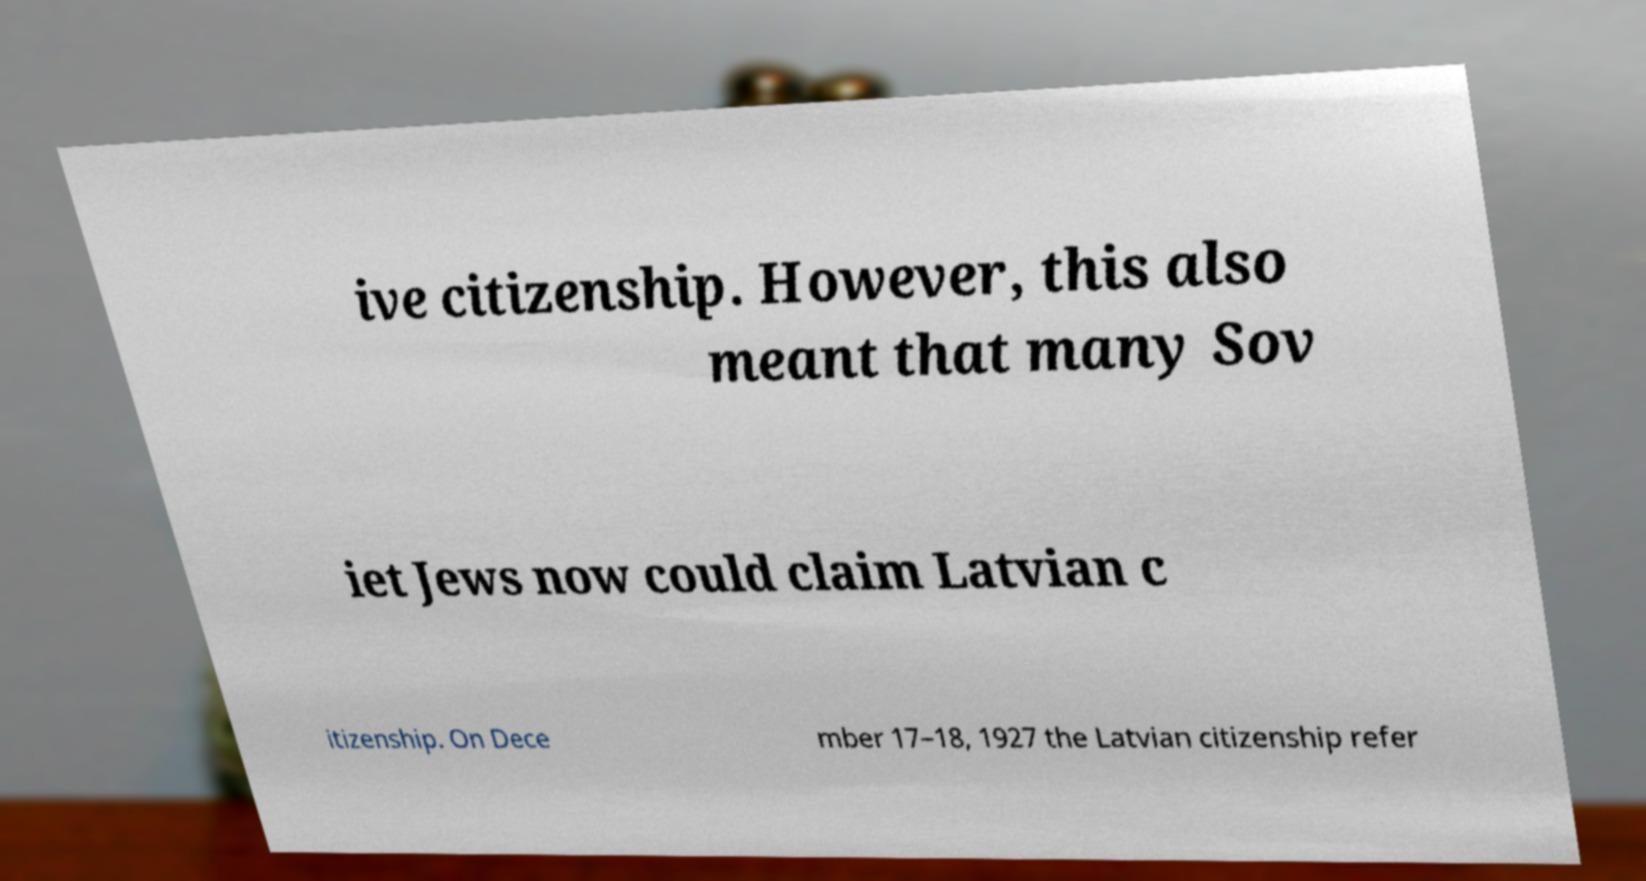For documentation purposes, I need the text within this image transcribed. Could you provide that? ive citizenship. However, this also meant that many Sov iet Jews now could claim Latvian c itizenship. On Dece mber 17–18, 1927 the Latvian citizenship refer 